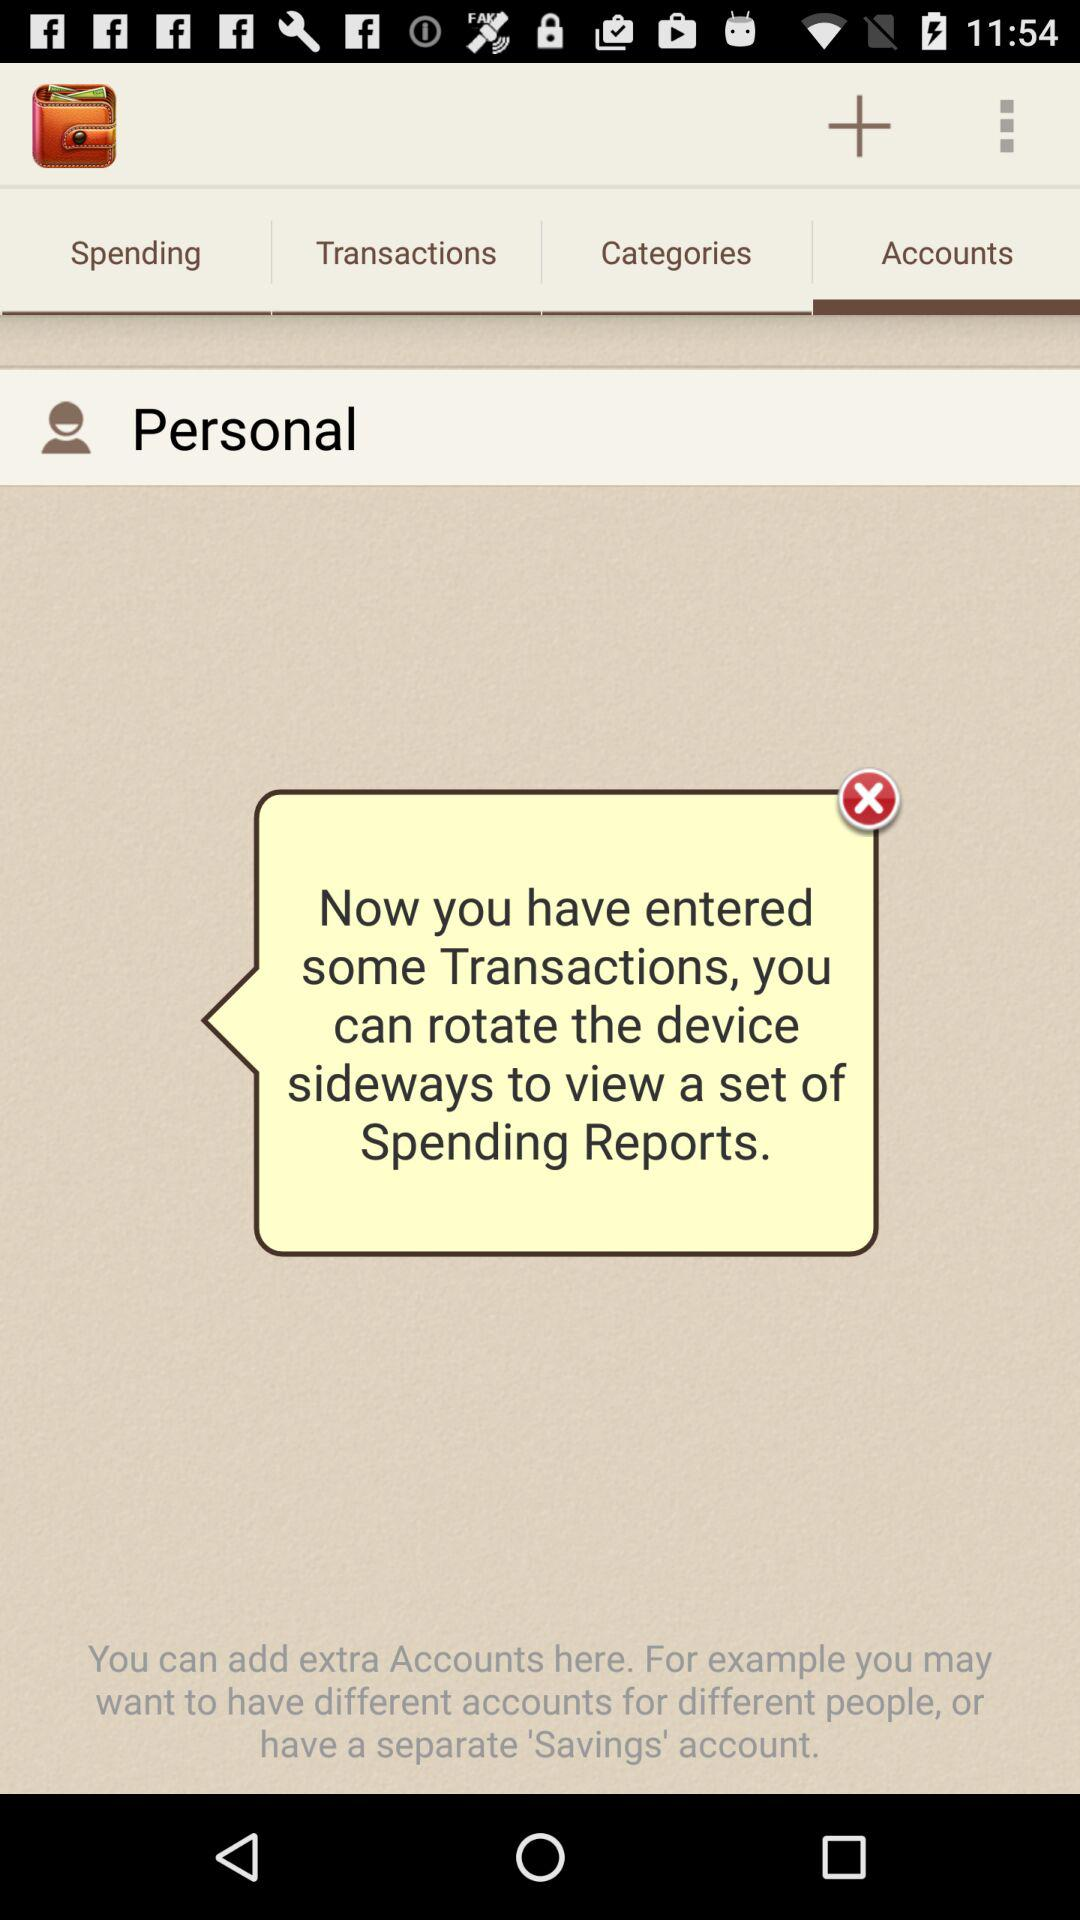What kind of transactions are there?
When the provided information is insufficient, respond with <no answer>. <no answer> 